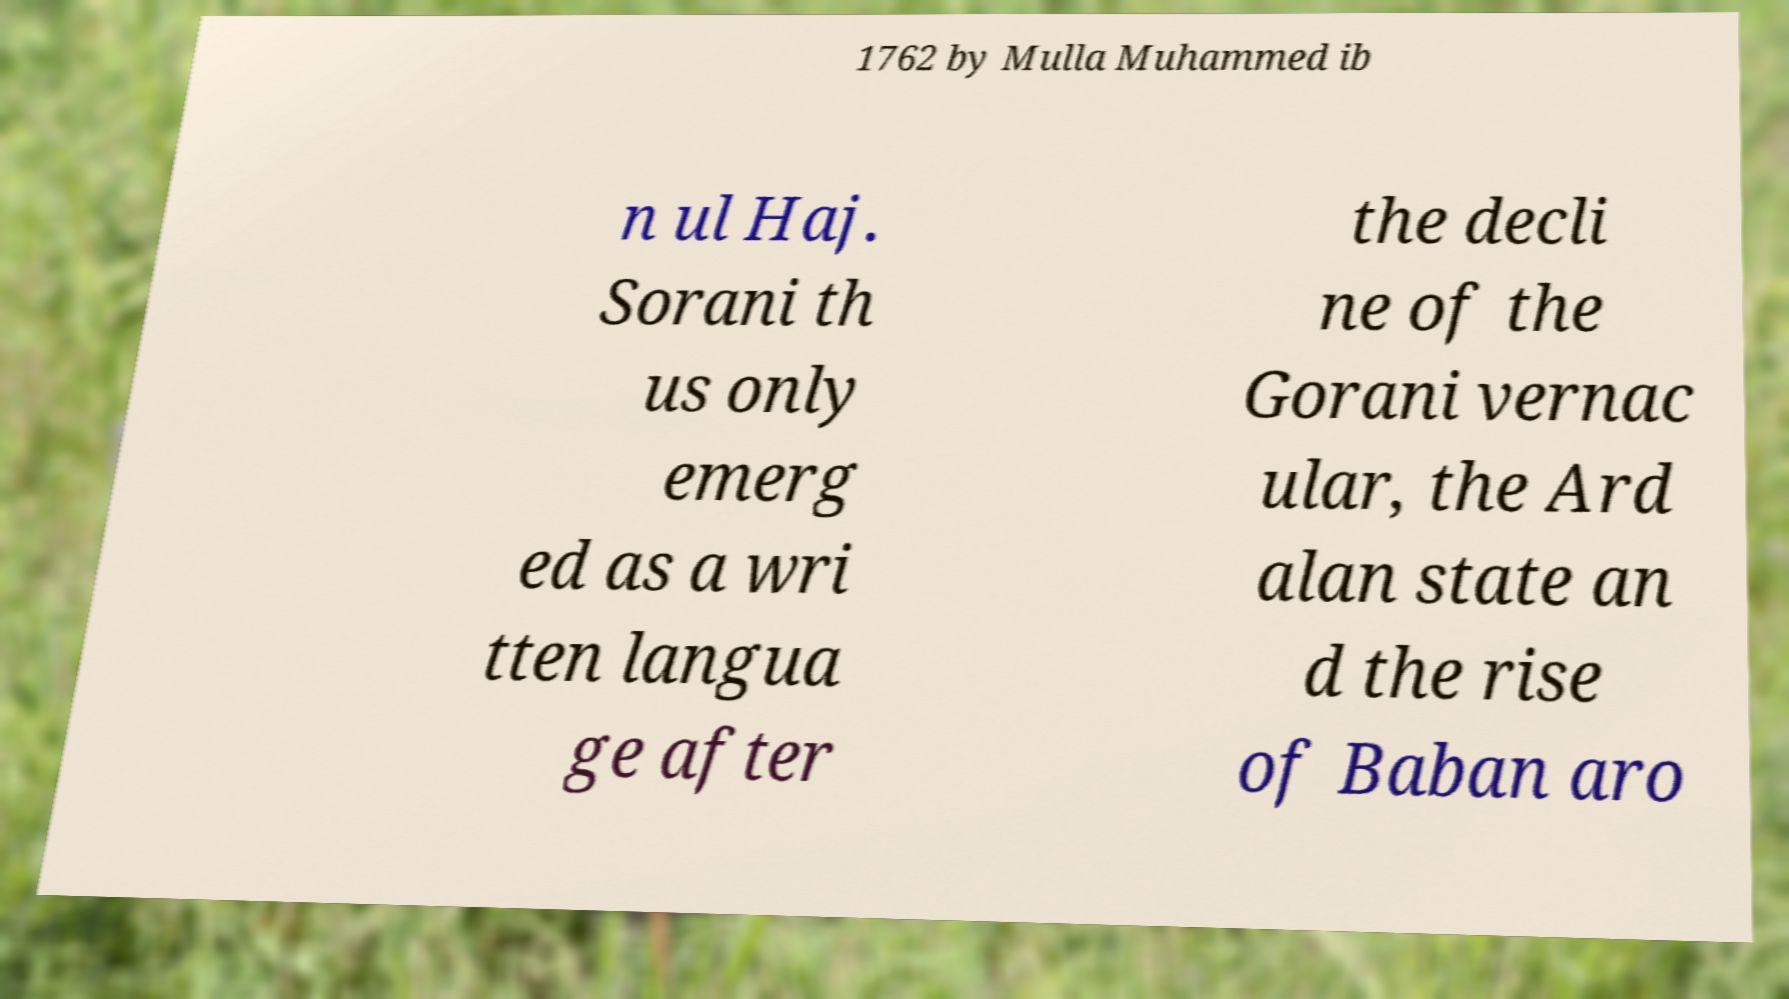I need the written content from this picture converted into text. Can you do that? 1762 by Mulla Muhammed ib n ul Haj. Sorani th us only emerg ed as a wri tten langua ge after the decli ne of the Gorani vernac ular, the Ard alan state an d the rise of Baban aro 